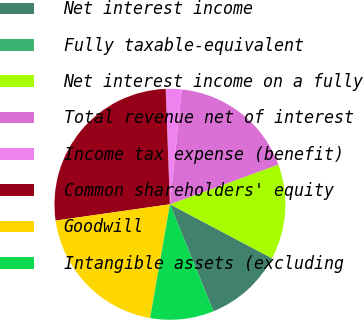Convert chart. <chart><loc_0><loc_0><loc_500><loc_500><pie_chart><fcel>Net interest income<fcel>Fully taxable-equivalent<fcel>Net interest income on a fully<fcel>Total revenue net of interest<fcel>Income tax expense (benefit)<fcel>Common shareholders' equity<fcel>Goodwill<fcel>Intangible assets (excluding<nl><fcel>11.11%<fcel>0.0%<fcel>13.33%<fcel>17.78%<fcel>2.22%<fcel>26.66%<fcel>20.0%<fcel>8.89%<nl></chart> 